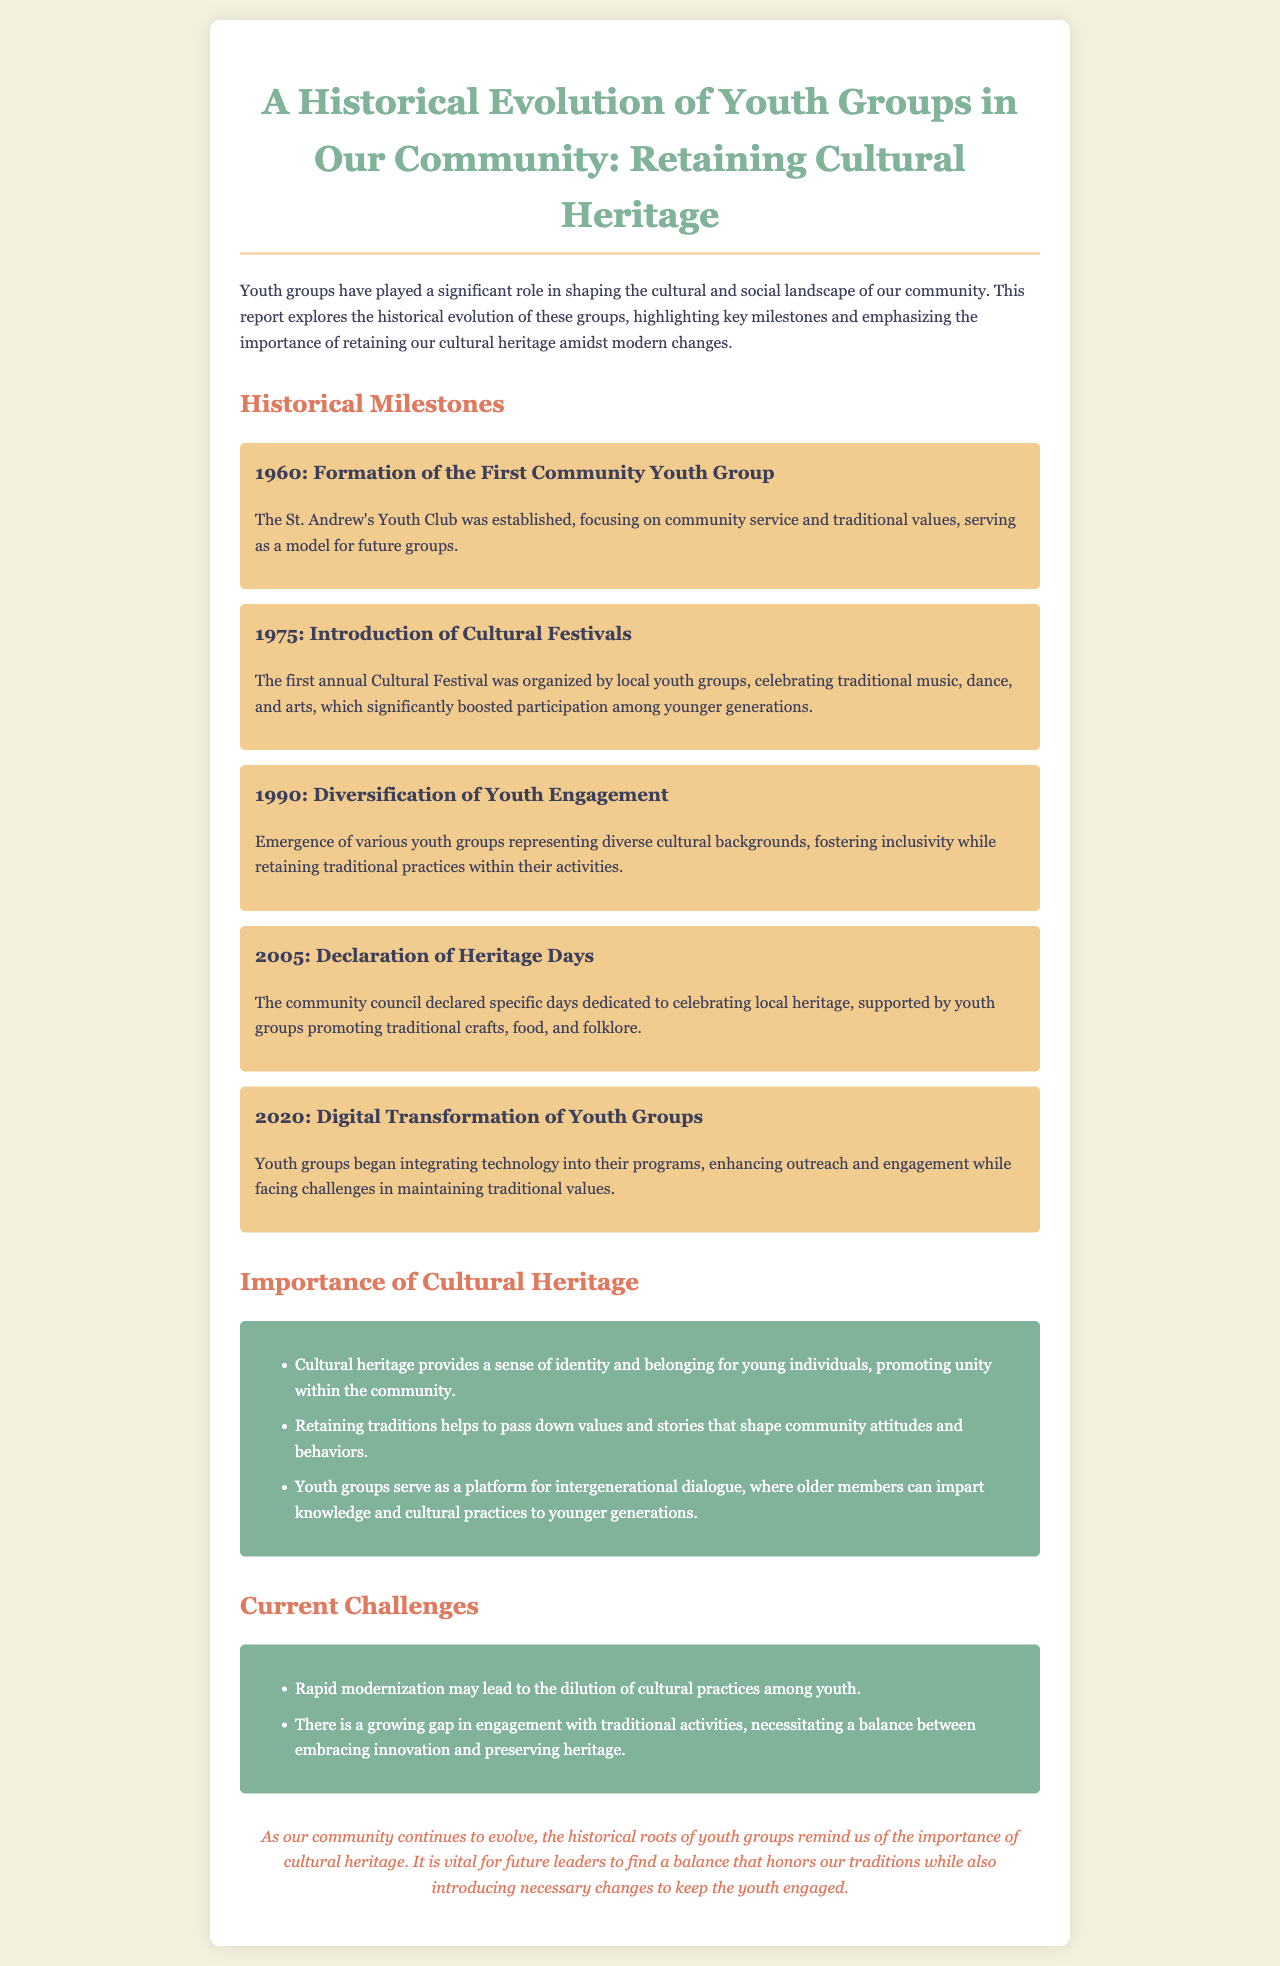What year was the first community youth group established? The document states that the St. Andrew's Youth Club was established in 1960.
Answer: 1960 What does the first annual Cultural Festival celebrate? The Cultural Festival celebrates traditional music, dance, and arts according to the report.
Answer: Traditional music, dance, and arts What significant event occurred in 2005 related to heritage? The community council declared specific days dedicated to celebrating local heritage in 2005.
Answer: Declaration of Heritage Days How many key points are listed under the importance of cultural heritage? The document lists three key points on the importance of cultural heritage.
Answer: Three What challenge do youth groups face related to modernization? The document mentions the rapid modernization may lead to the dilution of cultural practices among youth as a challenge.
Answer: Dilution of cultural practices What role do youth groups play in intergenerational dialogue? The report states that youth groups serve as a platform for intergenerational dialogue, imparting cultural practices.
Answer: Platform for intergenerational dialogue What is emphasized as vital for future leaders? The conclusion emphasizes the importance of finding a balance that honors traditions while introducing changes.
Answer: Finding a balance What year marked the digital transformation of youth groups? The document specifies that the digital transformation of youth groups began in 2020.
Answer: 2020 